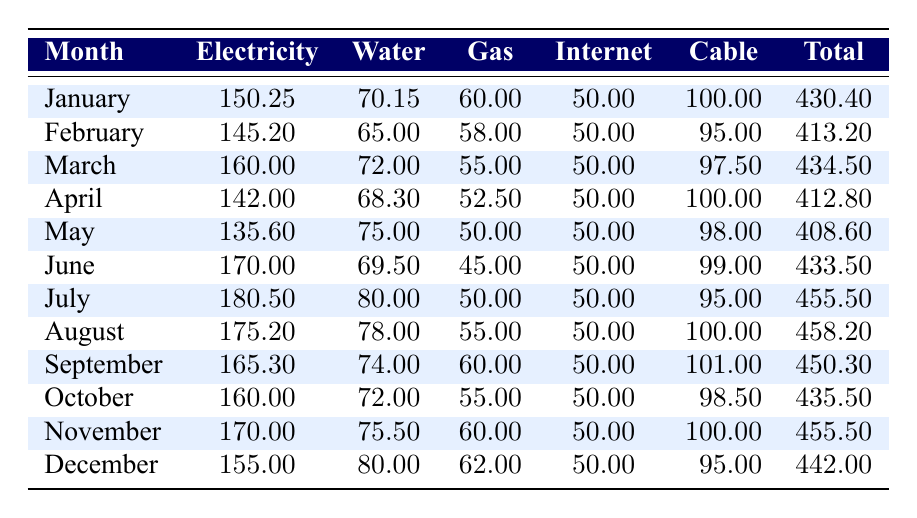What was the total utility expense for July 2023? Referring to the table, for July 2023, the total utility expense is listed as 455.50.
Answer: 455.50 What was the average electricity expense for the months of January and February 2023? The electricity expenses for January and February are 150.25 and 145.20, respectively. The average is calculated as (150.25 + 145.20) / 2 = 147.725.
Answer: 147.73 Which month had the highest total utility expense? Looking at the total expenses, July 2023 has the highest total of 455.50.
Answer: July 2023 Did any month have a total utility expense below 400? By reviewing the total expenses, the minimum total is 408.60 for May 2023, which confirms that no month had a total below 400.
Answer: No What was the percentage increase in total utility expense from January to March 2023? The total for January is 430.40 and for March it is 434.50. The increase is 434.50 - 430.40 = 4.10. The percentage increase is (4.10 / 430.40) * 100 = 0.95%.
Answer: 0.95% Which month had the lowest water expense, and what was the amount? Checking the water expenses, February 2023 has the lowest at 65.00.
Answer: February 2023, 65.00 What is the difference between the highest and lowest gas expenses over the year? The highest gas expense is 62.00 in December, and the lowest is 45.00 in June. The difference is 62.00 - 45.00 = 17.00.
Answer: 17.00 If the average internet expense is to be calculated for the year 2023, what will it be? The total internet expense for all months is 50.00 (for January) + 50.00 (February) + ... + 50.00 (December). There are 12 months, so the total is 600.00. The average is 600.00 / 12 = 50.00.
Answer: 50.00 In which month did the electricity expense exceed 170, and what was the amount? By reviewing the electricity expenses, only July is above 170, with a total of 180.50.
Answer: July 2023, 180.50 How does the total utility expense for December compare with that for November? The total for December 2023 is 442.00 and for November it is 455.50. The difference is 455.50 - 442.00 = 13.50, indicating December is lower.
Answer: December is lower by 13.50 